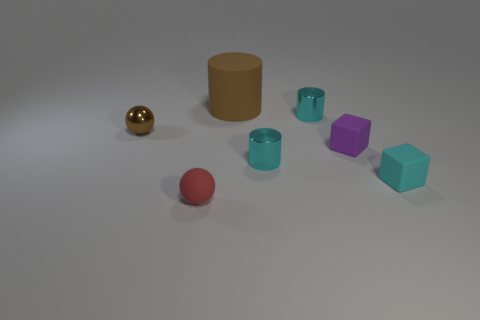What size is the ball that is the same color as the big rubber cylinder?
Provide a short and direct response. Small. Is there any other thing that has the same color as the matte ball?
Make the answer very short. No. There is a tiny purple object that is made of the same material as the large brown object; what is its shape?
Give a very brief answer. Cube. Do the cylinder in front of the purple rubber object and the small brown thing have the same material?
Offer a terse response. Yes. What shape is the metal thing that is the same color as the big rubber cylinder?
Your response must be concise. Sphere. There is a large matte object that is on the right side of the tiny red sphere; is it the same color as the ball behind the small purple rubber block?
Provide a succinct answer. Yes. How many small cyan things are both in front of the small purple matte object and behind the small cyan matte cube?
Give a very brief answer. 1. What material is the big cylinder?
Offer a terse response. Rubber. What shape is the purple thing that is the same size as the red rubber thing?
Provide a short and direct response. Cube. Is the small cylinder that is behind the small brown thing made of the same material as the brown object behind the small brown sphere?
Provide a short and direct response. No. 